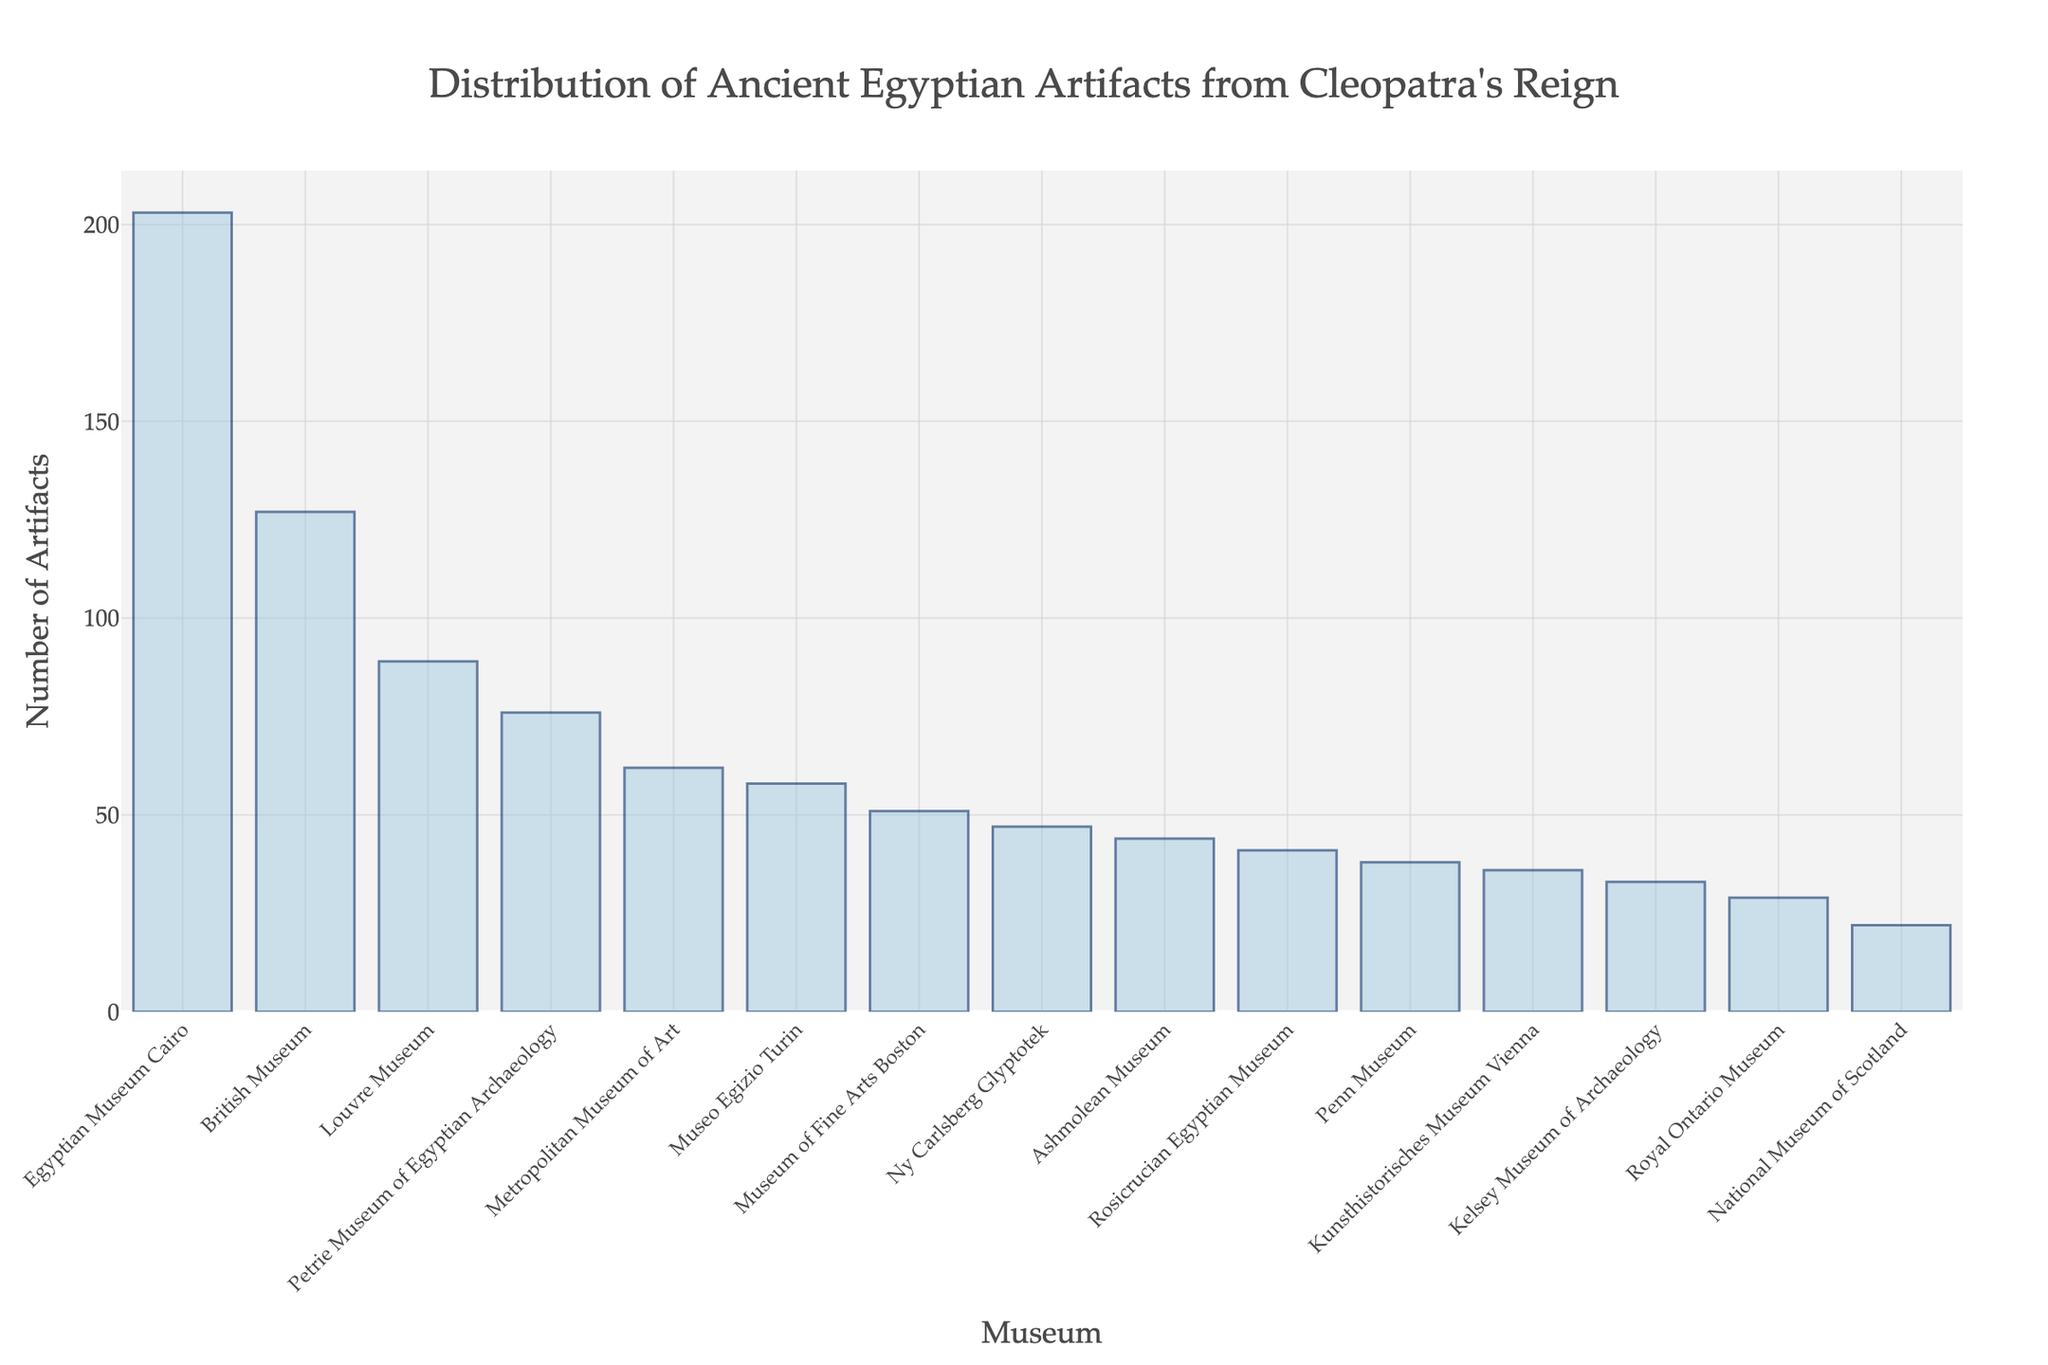Which museum has the highest number of artifacts from Cleopatra's reign? The Egyptian Museum Cairo has the tallest bar in the chart, indicating it has the highest number of artifacts.
Answer: Egyptian Museum Cairo Which museum has the least number of artifacts from Cleopatra's reign? The National Museum of Scotland has the shortest bar in the chart, indicating it has the least number of artifacts.
Answer: National Museum of Scotland What is the difference in the number of artifacts between the British Museum and the Louvre Museum? The British Museum has 127 artifacts, while the Louvre Museum has 89. The difference is 127 - 89 = 38.
Answer: 38 How many more artifacts does the Egyptian Museum Cairo have compared to the Metropolitan Museum of Art? The Egyptian Museum Cairo has 203 artifacts, while the Metropolitan Museum of Art has 62. The difference is 203 - 62 = 141.
Answer: 141 How many museums have more than 50 artifacts from Cleopatra's reign? By counting the bars with heights exceeding 50 on the figure, we find that six museums exceed 50 artifacts: British Museum, Egyptian Museum Cairo, Louvre Museum, Metropolitan Museum of Art, Petrie Museum of Egyptian Archaeology, and Museum of Fine Arts Boston.
Answer: 6 What is the total number of artifacts from Cleopatra's reign at the Kunsthistorisches Museum Vienna and the Penn Museum combined? The Kunsthistorisches Museum Vienna has 36 artifacts, and the Penn Museum has 38. Adding these together gives 36 + 38 = 74.
Answer: 74 Which museum has fewer artifacts: the Ashmolean Museum or the Rosicrucian Egyptian Museum? The Ashmolean Museum has 44 artifacts, while the Rosicrucian Egyptian Museum has 41. Therefore, the Rosicrucian Egyptian Museum has fewer artifacts.
Answer: Rosicrucian Egyptian Museum What is the combined number of artifacts from Cleopatra's reign in the three museums with the highest artifact counts? The three museums with the highest counts are the Egyptian Museum Cairo (203), British Museum (127), and Louvre Museum (89). Adding these together gives 203 + 127 + 89 = 419.
Answer: 419 By how much did the Rosicrucian Egyptian Museum fall short of the Metropolitan Museum of Art in terms of artifact count? The Metropolitan Museum of Art has 62 artifacts, and the Rosicrucian Egyptian Museum has 41. The difference is 62 - 41 = 21.
Answer: 21 How many more artifacts does the British Museum have compared to the average number of artifacts across all museums? First, we find the total number of artifacts across all museums. Summing the artifacts gives 951. There are 15 museums, so the average is 951 / 15 = 63.4. Comparing the British Museum's 127 artifacts to this average: 127 - 63.4 = 63.6.
Answer: 63.6 